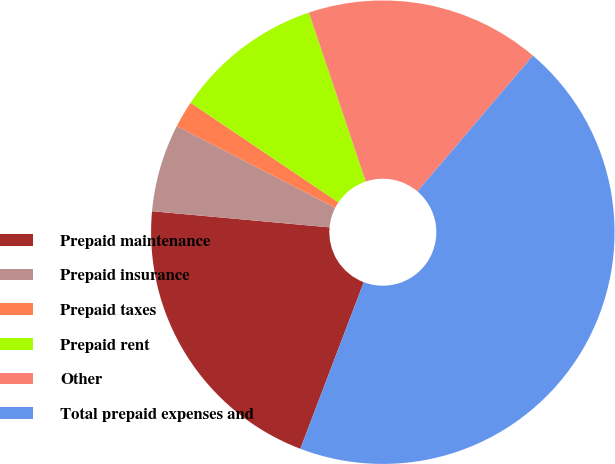<chart> <loc_0><loc_0><loc_500><loc_500><pie_chart><fcel>Prepaid maintenance<fcel>Prepaid insurance<fcel>Prepaid taxes<fcel>Prepaid rent<fcel>Other<fcel>Total prepaid expenses and<nl><fcel>20.65%<fcel>6.13%<fcel>1.86%<fcel>10.4%<fcel>16.38%<fcel>44.57%<nl></chart> 